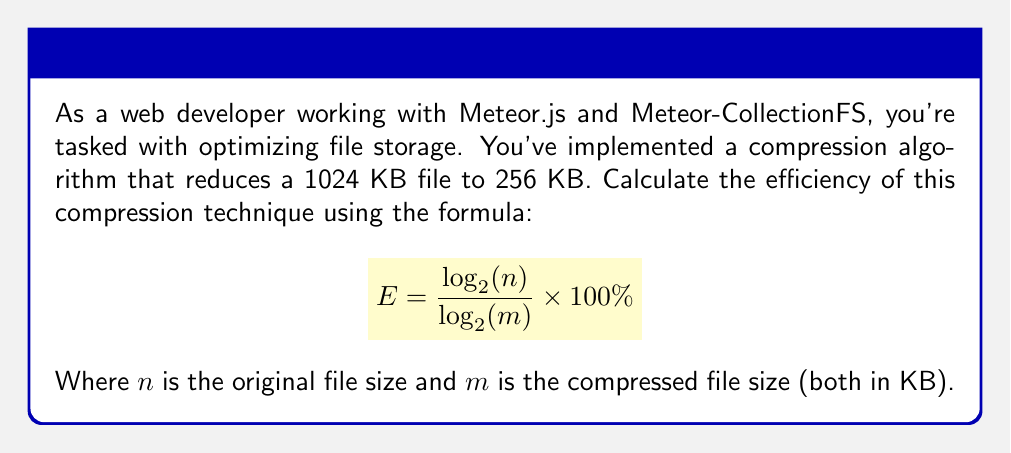Can you answer this question? Let's approach this step-by-step:

1) We're given:
   $n = 1024$ KB (original file size)
   $m = 256$ KB (compressed file size)

2) We need to use the formula:
   $$ E = \frac{\log_2(n)}{\log_2(m)} \times 100\% $$

3) Let's substitute our values:
   $$ E = \frac{\log_2(1024)}{\log_2(256)} \times 100\% $$

4) Simplify the logarithms:
   $\log_2(1024) = 10$ (because $2^{10} = 1024$)
   $\log_2(256) = 8$ (because $2^8 = 256$)

5) Now our equation looks like:
   $$ E = \frac{10}{8} \times 100\% $$

6) Divide:
   $$ E = 1.25 \times 100\% $$

7) Calculate the final percentage:
   $$ E = 125\% $$

This means the compression algorithm is 125% efficient, or it compresses the data by 25% more than what would be needed to just store the data without any redundancy.
Answer: 125% 